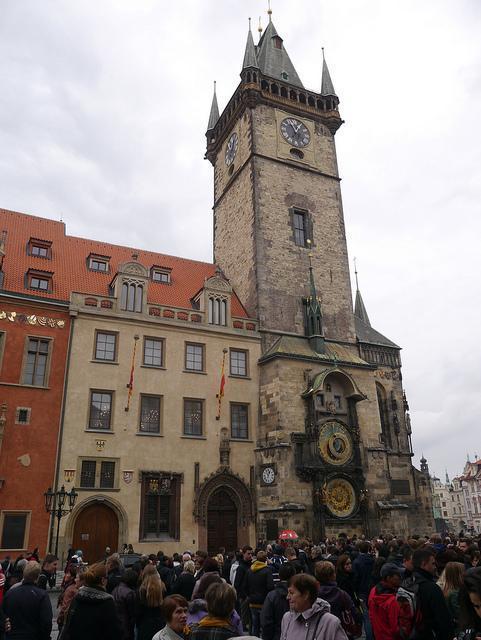How many redheads do you see?
Give a very brief answer. 0. How many people are there?
Give a very brief answer. 7. 